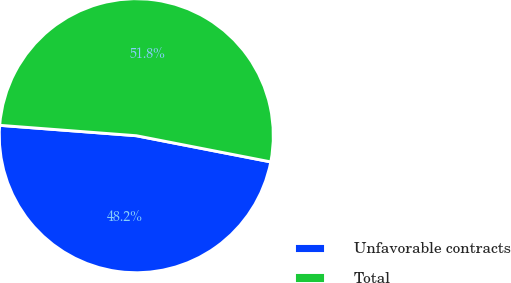<chart> <loc_0><loc_0><loc_500><loc_500><pie_chart><fcel>Unfavorable contracts<fcel>Total<nl><fcel>48.15%<fcel>51.85%<nl></chart> 